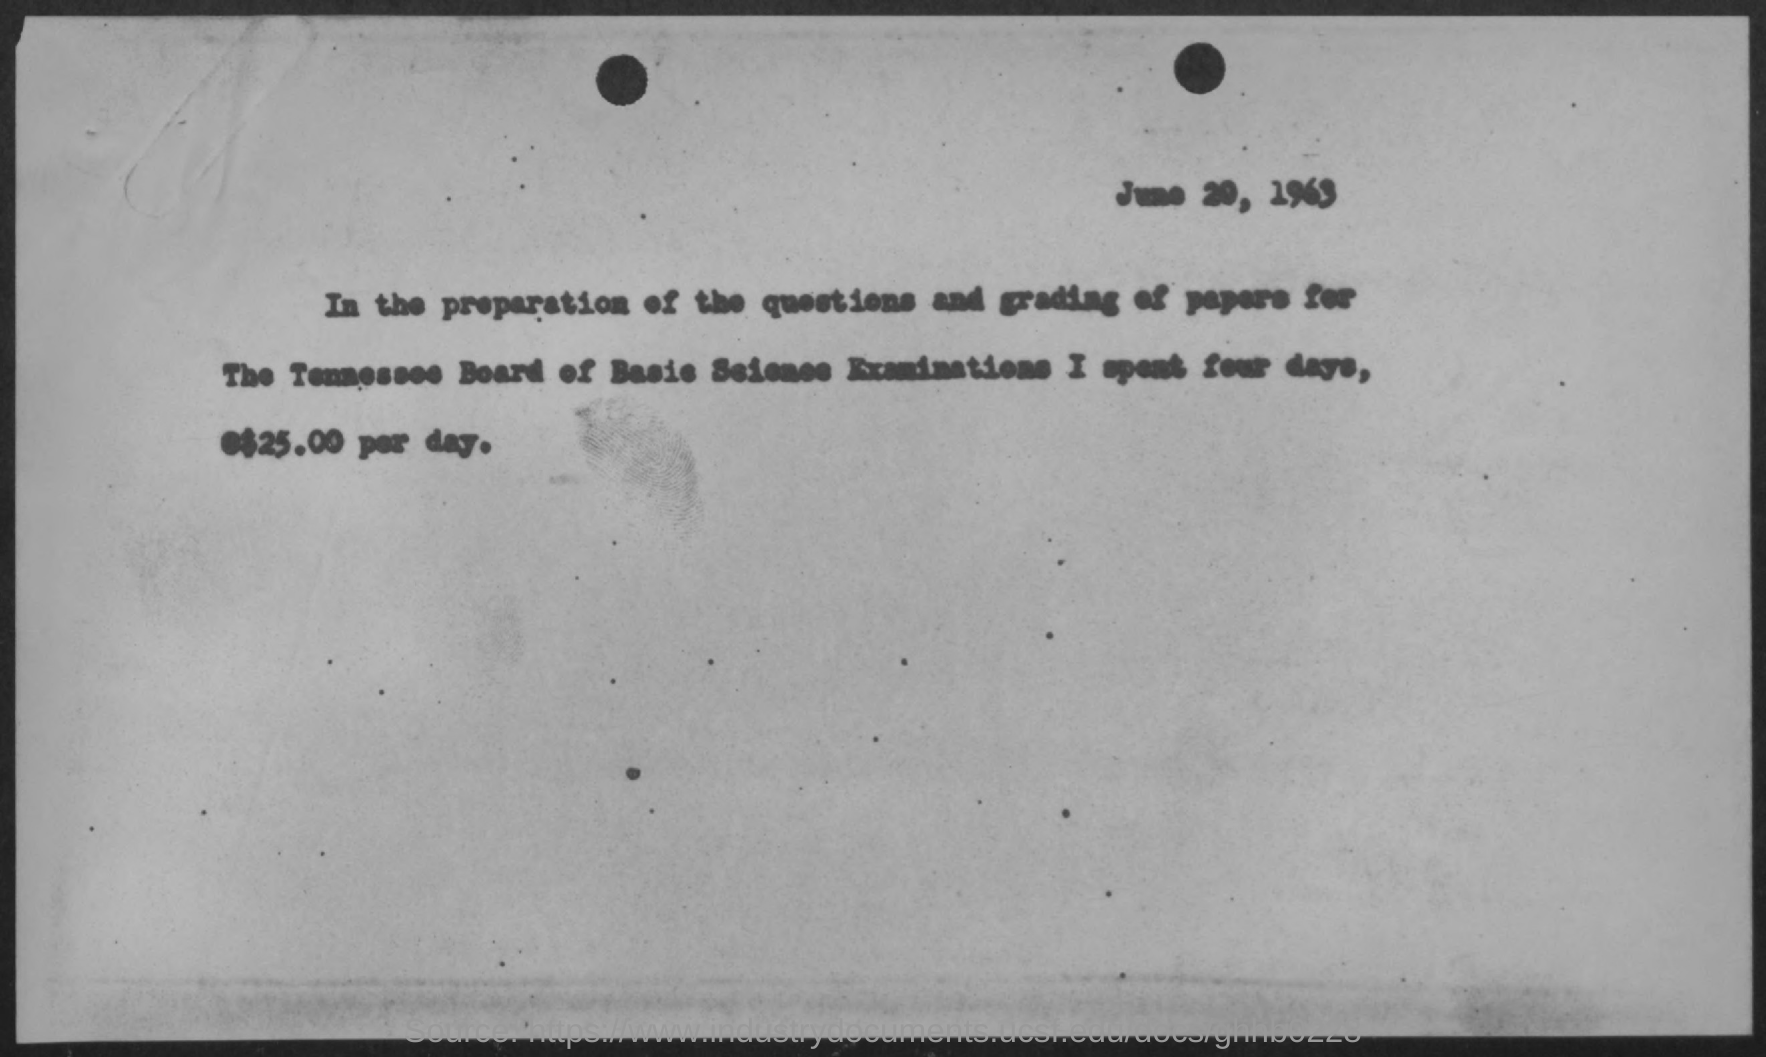Identify some key points in this picture. The year at the top is 1963. 